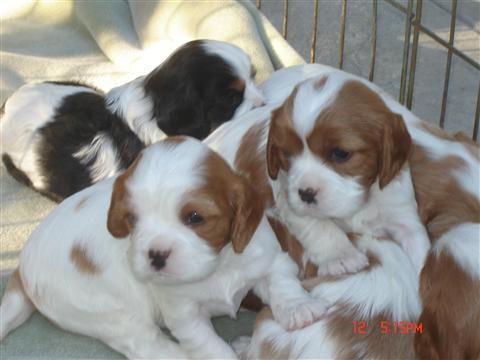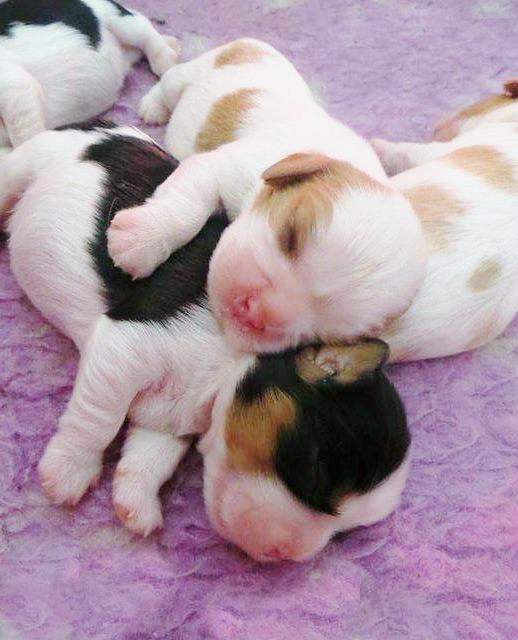The first image is the image on the left, the second image is the image on the right. Examine the images to the left and right. Is the description "The right image shows an adult, brown and white colored cocker spaniel mom with multiple puppies nursing" accurate? Answer yes or no. No. The first image is the image on the left, the second image is the image on the right. Examine the images to the left and right. Is the description "Multiple white-and-orange puppies pose upright and side-by-side in some type of container." accurate? Answer yes or no. No. 